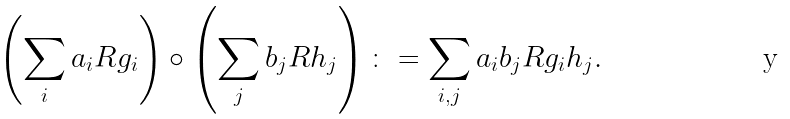Convert formula to latex. <formula><loc_0><loc_0><loc_500><loc_500>\left ( \sum _ { i } a _ { i } R g _ { i } \right ) \circ \left ( \sum _ { j } b _ { j } R h _ { j } \right ) \colon = \sum _ { i , j } a _ { i } b _ { j } R g _ { i } h _ { j } .</formula> 